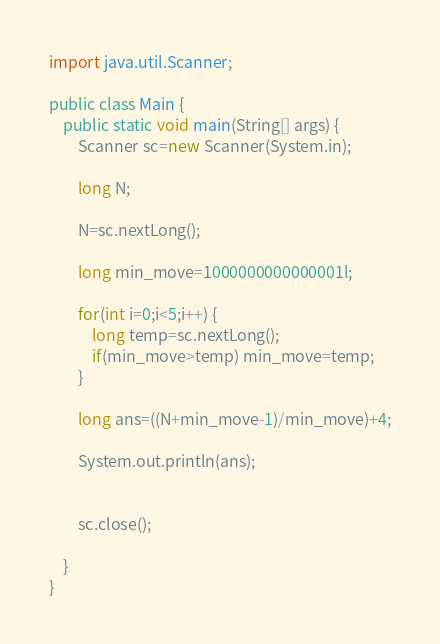<code> <loc_0><loc_0><loc_500><loc_500><_Java_>import java.util.Scanner;

public class Main {
	public static void main(String[] args) {
		Scanner sc=new Scanner(System.in);

		long N;

		N=sc.nextLong();

		long min_move=1000000000000001l;

		for(int i=0;i<5;i++) {
			long temp=sc.nextLong();
			if(min_move>temp) min_move=temp;
		}

		long ans=((N+min_move-1)/min_move)+4;

		System.out.println(ans);


		sc.close();

	}
}
</code> 